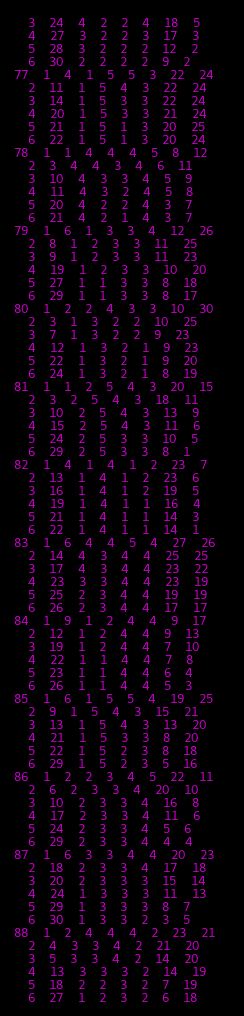<code> <loc_0><loc_0><loc_500><loc_500><_ObjectiveC_>	3	24	4	2	2	4	18	5	
	4	27	3	2	2	3	17	3	
	5	28	3	2	2	2	12	2	
	6	30	2	2	2	2	9	2	
77	1	4	1	5	5	3	22	24	
	2	11	1	5	4	3	22	24	
	3	14	1	5	3	3	22	24	
	4	20	1	5	3	3	21	24	
	5	21	1	5	1	3	20	25	
	6	22	1	5	1	3	20	24	
78	1	1	4	4	4	5	8	12	
	2	3	4	4	3	4	6	11	
	3	10	4	3	3	4	5	9	
	4	11	4	3	2	4	5	8	
	5	20	4	2	2	4	3	7	
	6	21	4	2	1	4	3	7	
79	1	6	1	3	3	4	12	26	
	2	8	1	2	3	3	11	25	
	3	9	1	2	3	3	11	23	
	4	19	1	2	3	3	10	20	
	5	27	1	1	3	3	8	18	
	6	29	1	1	3	3	8	17	
80	1	2	2	4	3	3	10	30	
	2	3	1	3	2	2	10	25	
	3	7	1	3	2	2	9	23	
	4	12	1	3	2	1	9	23	
	5	22	1	3	2	1	9	20	
	6	24	1	3	2	1	8	19	
81	1	1	2	5	4	3	20	15	
	2	3	2	5	4	3	18	11	
	3	10	2	5	4	3	13	9	
	4	15	2	5	4	3	11	6	
	5	24	2	5	3	3	10	5	
	6	29	2	5	3	3	8	1	
82	1	4	1	4	1	2	23	7	
	2	13	1	4	1	2	23	6	
	3	16	1	4	1	2	19	5	
	4	19	1	4	1	1	16	4	
	5	21	1	4	1	1	14	3	
	6	22	1	4	1	1	14	1	
83	1	6	4	4	5	4	27	26	
	2	14	4	3	4	4	25	25	
	3	17	4	3	4	4	23	22	
	4	23	3	3	4	4	23	19	
	5	25	2	3	4	4	19	19	
	6	26	2	3	4	4	17	17	
84	1	9	1	2	4	4	9	17	
	2	12	1	2	4	4	9	13	
	3	19	1	2	4	4	7	10	
	4	22	1	1	4	4	7	8	
	5	23	1	1	4	4	6	4	
	6	26	1	1	4	4	5	3	
85	1	6	1	5	5	4	19	25	
	2	9	1	5	4	3	15	21	
	3	13	1	5	4	3	13	20	
	4	21	1	5	3	3	8	20	
	5	22	1	5	2	3	8	18	
	6	29	1	5	2	3	5	16	
86	1	2	2	3	4	5	22	11	
	2	6	2	3	3	4	20	10	
	3	10	2	3	3	4	16	8	
	4	17	2	3	3	4	11	6	
	5	24	2	3	3	4	5	6	
	6	29	2	3	3	4	4	4	
87	1	6	3	3	4	4	20	23	
	2	18	2	3	3	4	17	18	
	3	20	2	3	3	3	15	14	
	4	24	1	3	3	3	11	13	
	5	29	1	3	3	3	8	7	
	6	30	1	3	3	2	3	5	
88	1	2	4	4	4	2	23	21	
	2	4	3	3	4	2	21	20	
	3	5	3	3	4	2	14	20	
	4	13	3	3	3	2	14	19	
	5	18	2	2	3	2	7	19	
	6	27	1	2	3	2	6	18	</code> 